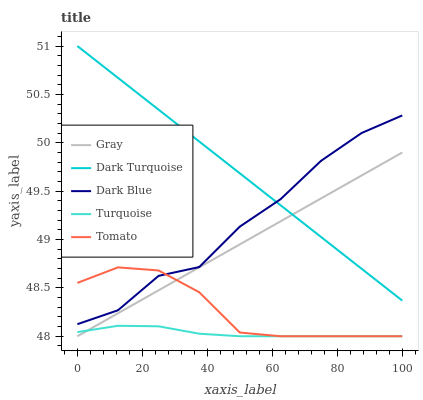Does Turquoise have the minimum area under the curve?
Answer yes or no. Yes. Does Dark Turquoise have the maximum area under the curve?
Answer yes or no. Yes. Does Gray have the minimum area under the curve?
Answer yes or no. No. Does Gray have the maximum area under the curve?
Answer yes or no. No. Is Dark Turquoise the smoothest?
Answer yes or no. Yes. Is Dark Blue the roughest?
Answer yes or no. Yes. Is Gray the smoothest?
Answer yes or no. No. Is Gray the roughest?
Answer yes or no. No. Does Tomato have the lowest value?
Answer yes or no. Yes. Does Dark Blue have the lowest value?
Answer yes or no. No. Does Dark Turquoise have the highest value?
Answer yes or no. Yes. Does Gray have the highest value?
Answer yes or no. No. Is Turquoise less than Dark Blue?
Answer yes or no. Yes. Is Dark Turquoise greater than Turquoise?
Answer yes or no. Yes. Does Gray intersect Turquoise?
Answer yes or no. Yes. Is Gray less than Turquoise?
Answer yes or no. No. Is Gray greater than Turquoise?
Answer yes or no. No. Does Turquoise intersect Dark Blue?
Answer yes or no. No. 